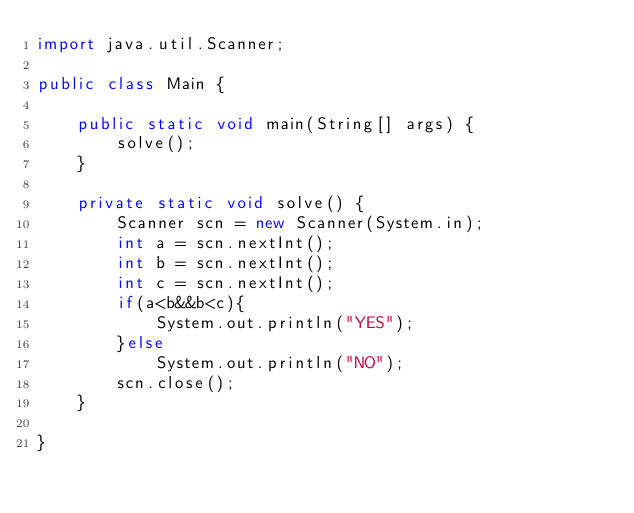<code> <loc_0><loc_0><loc_500><loc_500><_Java_>import java.util.Scanner;

public class Main {

	public static void main(String[] args) {
		solve();
	}

	private static void solve() {
		Scanner scn = new Scanner(System.in);
		int a = scn.nextInt();
		int b = scn.nextInt();
		int c = scn.nextInt();
		if(a<b&&b<c){
			System.out.println("YES");
		}else
			System.out.println("NO");
		scn.close();
	}

}</code> 